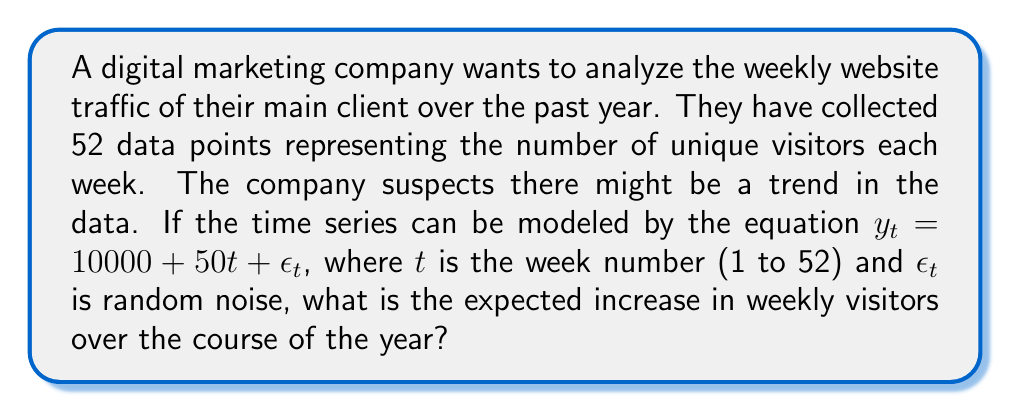Show me your answer to this math problem. To solve this problem, we need to understand the components of the given time series model:

1) $y_t = 10000 + 50t + \epsilon_t$

Where:
- $y_t$ is the number of visitors in week $t$
- $10000$ is the initial number of visitors (intercept)
- $50t$ represents the trend component
- $\epsilon_t$ is the random noise (which averages to zero over time)

2) The trend component is $50t$, which means the number of visitors increases by 50 each week.

3) To find the total increase over the year, we need to calculate the difference between week 52 and week 1:

   Week 52: $50 * 52 = 2600$
   Week 1: $50 * 1 = 50$

4) The difference is:
   $2600 - 50 = 2550$

Therefore, the expected increase in weekly visitors over the course of the year (52 weeks) is 2550.
Answer: 2550 visitors 